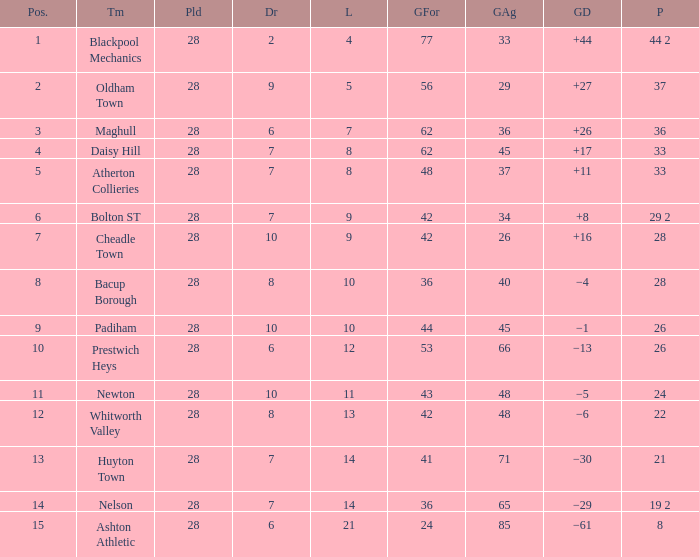For entries with lost larger than 21 and goals for smaller than 36, what is the average drawn? None. 